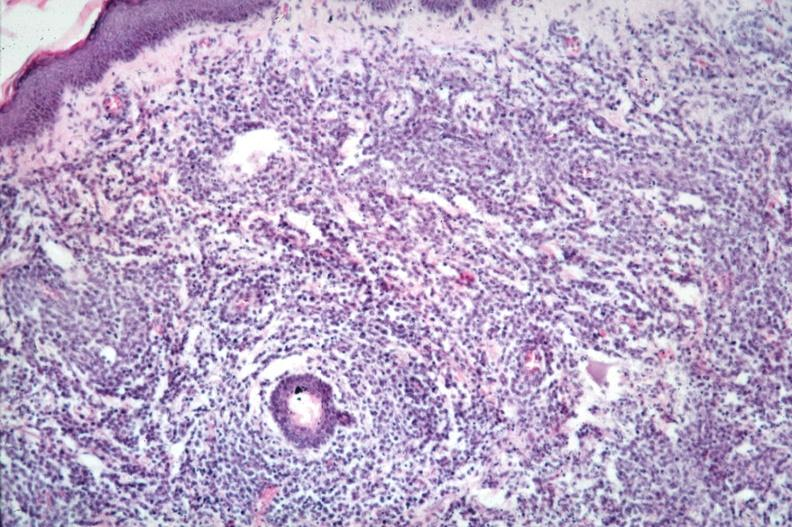does this image show dermal lymphoma infiltrate?
Answer the question using a single word or phrase. Yes 